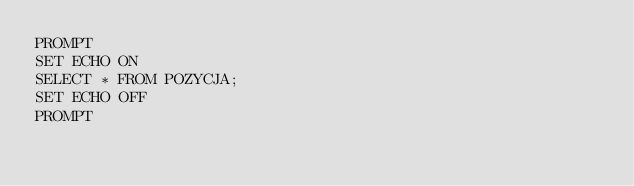Convert code to text. <code><loc_0><loc_0><loc_500><loc_500><_SQL_>PROMPT
SET ECHO ON
SELECT * FROM POZYCJA;
SET ECHO OFF
PROMPT</code> 